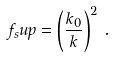Convert formula to latex. <formula><loc_0><loc_0><loc_500><loc_500>f _ { s } u p = \left ( \frac { k _ { 0 } } { k } \right ) ^ { 2 } \, .</formula> 